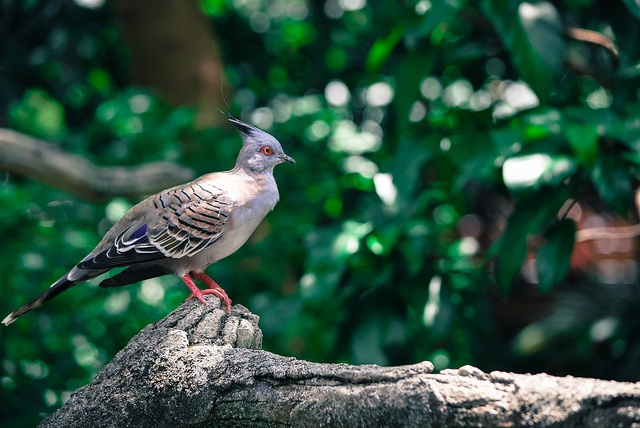Describe the objects in this image and their specific colors. I can see a bird in black, darkgray, gray, and lightgray tones in this image. 